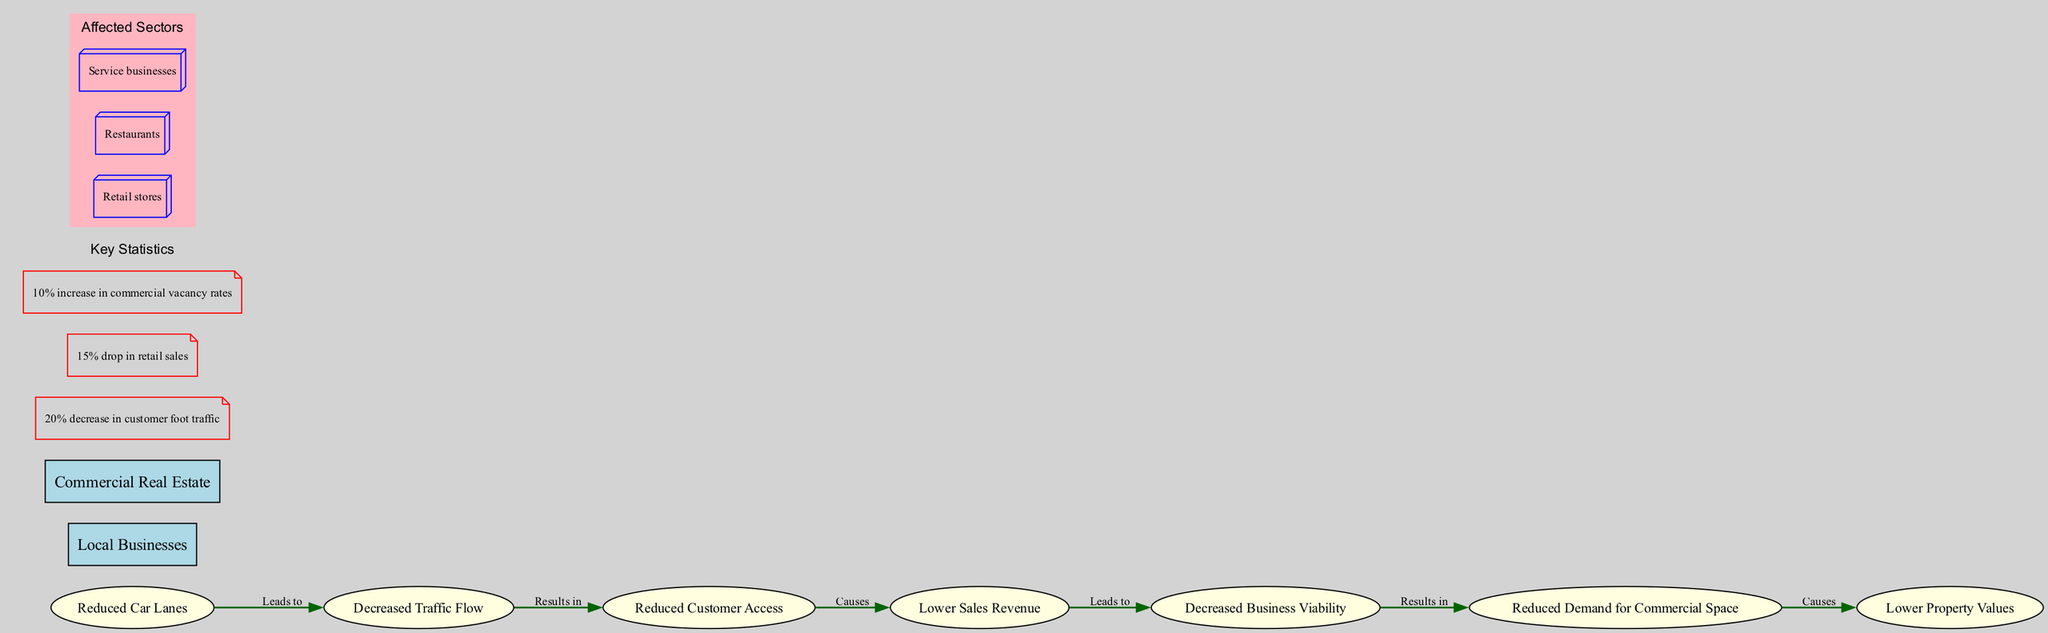What are the main components represented in the diagram? The main components listed in the diagram include "Reduced Car Lanes", "Local Businesses", and "Commercial Real Estate".
Answer: Reduced Car Lanes, Local Businesses, Commercial Real Estate What leads to decreased traffic flow? The diagram indicates that "Reduced Car Lanes" lead to "Decreased Traffic Flow".
Answer: Reduced Car Lanes What is the first impact step that results from decreased traffic flow? The flow in the diagram shows that "Decreased Traffic Flow" results in "Reduced Customer Access".
Answer: Reduced Customer Access How much is the decrease in customer foot traffic? According to the key statistics section of the diagram, there is a "20% decrease in customer foot traffic".
Answer: 20% Which business sector is directly affected by lower sales revenue? The diagram indicates that lower sales revenue affects "Retail stores", "Restaurants", and "Service businesses", but focusing on the direct relation, it is impacted across these sectors.
Answer: Retail stores, Restaurants, Service businesses What causes decreased business viability? The flow in the diagram indicates that "Lower Sales Revenue" causes "Decreased Business Viability".
Answer: Lower Sales Revenue What is the final outcome of reduced demand for commercial space? The diagram shows that "Reduced Demand for Commercial Space" causes "Lower Property Values".
Answer: Lower Property Values Which statistical data indicates a trend in commercial vacancy rates? The key statistics mention a "10% increase in commercial vacancy rates", indicating a negative trend in occupancy.
Answer: 10% What connects lower sales revenue to reduced demand for commercial space? The diagram illustrates that "Decreased Business Viability" leads to "Reduced Demand for Commercial Space", connecting them through the flow of impacts.
Answer: Decreased Business Viability What leads to lower property values? The diagram indicates that "Reduced Demand for Commercial Space" leads to "Lower Property Values".
Answer: Reduced Demand for Commercial Space 